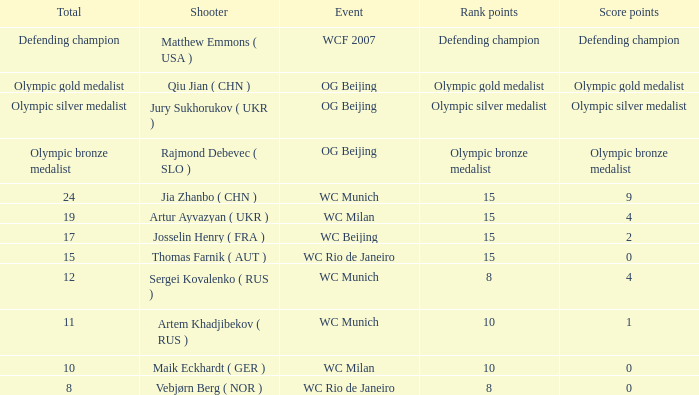Who was the shooter for the WC Beijing event? Josselin Henry ( FRA ). 